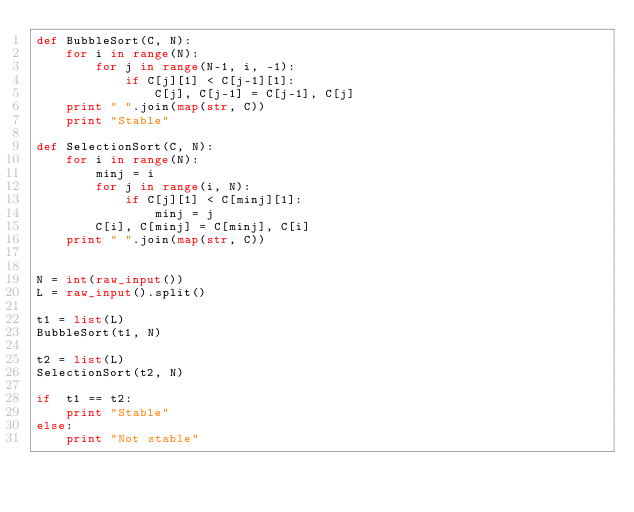<code> <loc_0><loc_0><loc_500><loc_500><_Python_>def BubbleSort(C, N):
    for i in range(N):
        for j in range(N-1, i, -1):
            if C[j][1] < C[j-1][1]:
                C[j], C[j-1] = C[j-1], C[j]
    print " ".join(map(str, C))
    print "Stable"

def SelectionSort(C, N):
    for i in range(N):
        minj = i
        for j in range(i, N):
            if C[j][1] < C[minj][1]:
                minj = j
        C[i], C[minj] = C[minj], C[i]
    print " ".join(map(str, C))


N = int(raw_input())
L = raw_input().split()

t1 = list(L)
BubbleSort(t1, N)

t2 = list(L)
SelectionSort(t2, N)

if  t1 == t2:
    print "Stable"
else:
    print "Not stable"</code> 